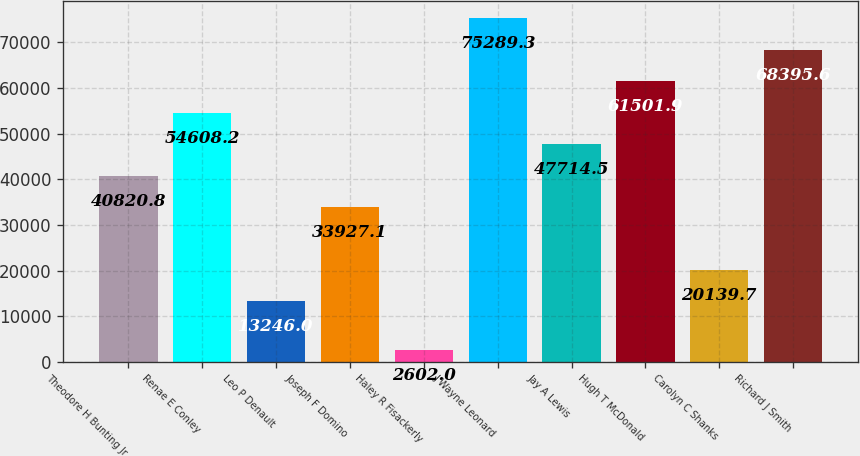Convert chart. <chart><loc_0><loc_0><loc_500><loc_500><bar_chart><fcel>Theodore H Bunting Jr<fcel>Renae E Conley<fcel>Leo P Denault<fcel>Joseph F Domino<fcel>Haley R Fisackerly<fcel>J Wayne Leonard<fcel>Jay A Lewis<fcel>Hugh T McDonald<fcel>Carolyn C Shanks<fcel>Richard J Smith<nl><fcel>40820.8<fcel>54608.2<fcel>13246<fcel>33927.1<fcel>2602<fcel>75289.3<fcel>47714.5<fcel>61501.9<fcel>20139.7<fcel>68395.6<nl></chart> 